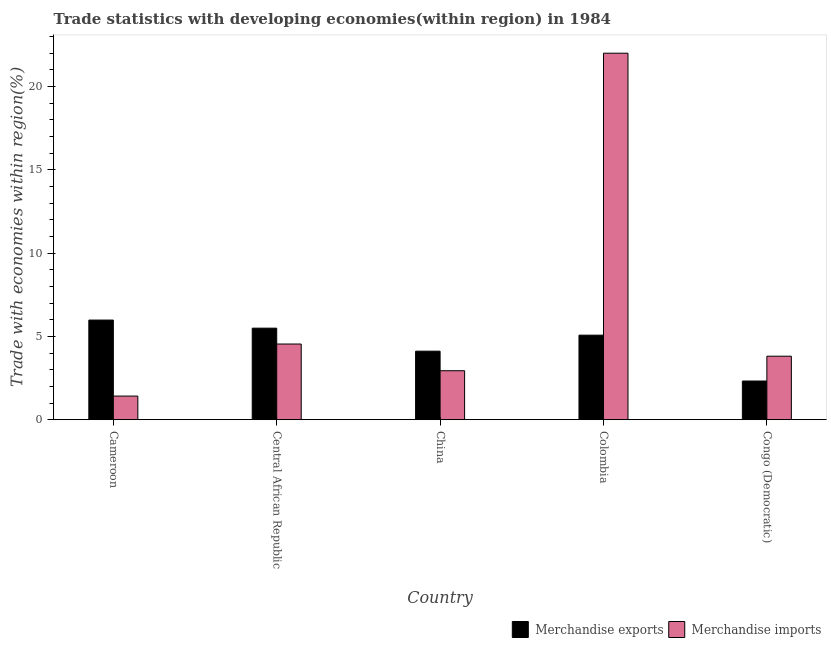How many different coloured bars are there?
Make the answer very short. 2. How many groups of bars are there?
Offer a very short reply. 5. How many bars are there on the 5th tick from the right?
Give a very brief answer. 2. What is the label of the 5th group of bars from the left?
Your response must be concise. Congo (Democratic). What is the merchandise exports in Central African Republic?
Offer a terse response. 5.5. Across all countries, what is the maximum merchandise imports?
Offer a very short reply. 22.01. Across all countries, what is the minimum merchandise exports?
Provide a short and direct response. 2.32. In which country was the merchandise imports minimum?
Offer a very short reply. Cameroon. What is the total merchandise imports in the graph?
Offer a terse response. 34.72. What is the difference between the merchandise imports in Central African Republic and that in Congo (Democratic)?
Your response must be concise. 0.73. What is the difference between the merchandise imports in Congo (Democratic) and the merchandise exports in Cameroon?
Your response must be concise. -2.17. What is the average merchandise exports per country?
Offer a terse response. 4.6. What is the difference between the merchandise exports and merchandise imports in Congo (Democratic)?
Ensure brevity in your answer.  -1.49. In how many countries, is the merchandise exports greater than 20 %?
Keep it short and to the point. 0. What is the ratio of the merchandise exports in Cameroon to that in Congo (Democratic)?
Ensure brevity in your answer.  2.58. Is the merchandise imports in China less than that in Colombia?
Give a very brief answer. Yes. What is the difference between the highest and the second highest merchandise exports?
Your response must be concise. 0.49. What is the difference between the highest and the lowest merchandise exports?
Keep it short and to the point. 3.66. In how many countries, is the merchandise exports greater than the average merchandise exports taken over all countries?
Keep it short and to the point. 3. Is the sum of the merchandise imports in Colombia and Congo (Democratic) greater than the maximum merchandise exports across all countries?
Your response must be concise. Yes. How many bars are there?
Provide a succinct answer. 10. How many countries are there in the graph?
Your answer should be very brief. 5. Does the graph contain any zero values?
Offer a very short reply. No. Where does the legend appear in the graph?
Make the answer very short. Bottom right. How many legend labels are there?
Give a very brief answer. 2. How are the legend labels stacked?
Ensure brevity in your answer.  Horizontal. What is the title of the graph?
Your answer should be very brief. Trade statistics with developing economies(within region) in 1984. What is the label or title of the X-axis?
Make the answer very short. Country. What is the label or title of the Y-axis?
Your answer should be compact. Trade with economies within region(%). What is the Trade with economies within region(%) in Merchandise exports in Cameroon?
Make the answer very short. 5.98. What is the Trade with economies within region(%) in Merchandise imports in Cameroon?
Provide a succinct answer. 1.42. What is the Trade with economies within region(%) in Merchandise exports in Central African Republic?
Offer a terse response. 5.5. What is the Trade with economies within region(%) in Merchandise imports in Central African Republic?
Offer a very short reply. 4.54. What is the Trade with economies within region(%) in Merchandise exports in China?
Provide a succinct answer. 4.11. What is the Trade with economies within region(%) of Merchandise imports in China?
Offer a very short reply. 2.94. What is the Trade with economies within region(%) in Merchandise exports in Colombia?
Keep it short and to the point. 5.08. What is the Trade with economies within region(%) of Merchandise imports in Colombia?
Offer a very short reply. 22.01. What is the Trade with economies within region(%) in Merchandise exports in Congo (Democratic)?
Your response must be concise. 2.32. What is the Trade with economies within region(%) of Merchandise imports in Congo (Democratic)?
Your answer should be very brief. 3.81. Across all countries, what is the maximum Trade with economies within region(%) in Merchandise exports?
Your response must be concise. 5.98. Across all countries, what is the maximum Trade with economies within region(%) in Merchandise imports?
Ensure brevity in your answer.  22.01. Across all countries, what is the minimum Trade with economies within region(%) of Merchandise exports?
Your answer should be compact. 2.32. Across all countries, what is the minimum Trade with economies within region(%) in Merchandise imports?
Your answer should be compact. 1.42. What is the total Trade with economies within region(%) of Merchandise exports in the graph?
Provide a succinct answer. 22.99. What is the total Trade with economies within region(%) in Merchandise imports in the graph?
Offer a very short reply. 34.72. What is the difference between the Trade with economies within region(%) in Merchandise exports in Cameroon and that in Central African Republic?
Make the answer very short. 0.49. What is the difference between the Trade with economies within region(%) in Merchandise imports in Cameroon and that in Central African Republic?
Your response must be concise. -3.13. What is the difference between the Trade with economies within region(%) in Merchandise exports in Cameroon and that in China?
Offer a very short reply. 1.87. What is the difference between the Trade with economies within region(%) in Merchandise imports in Cameroon and that in China?
Offer a terse response. -1.52. What is the difference between the Trade with economies within region(%) in Merchandise exports in Cameroon and that in Colombia?
Your answer should be very brief. 0.91. What is the difference between the Trade with economies within region(%) of Merchandise imports in Cameroon and that in Colombia?
Keep it short and to the point. -20.59. What is the difference between the Trade with economies within region(%) of Merchandise exports in Cameroon and that in Congo (Democratic)?
Offer a very short reply. 3.66. What is the difference between the Trade with economies within region(%) of Merchandise imports in Cameroon and that in Congo (Democratic)?
Provide a succinct answer. -2.39. What is the difference between the Trade with economies within region(%) of Merchandise exports in Central African Republic and that in China?
Your answer should be very brief. 1.38. What is the difference between the Trade with economies within region(%) of Merchandise imports in Central African Republic and that in China?
Offer a very short reply. 1.6. What is the difference between the Trade with economies within region(%) in Merchandise exports in Central African Republic and that in Colombia?
Keep it short and to the point. 0.42. What is the difference between the Trade with economies within region(%) of Merchandise imports in Central African Republic and that in Colombia?
Give a very brief answer. -17.46. What is the difference between the Trade with economies within region(%) in Merchandise exports in Central African Republic and that in Congo (Democratic)?
Your response must be concise. 3.17. What is the difference between the Trade with economies within region(%) of Merchandise imports in Central African Republic and that in Congo (Democratic)?
Ensure brevity in your answer.  0.73. What is the difference between the Trade with economies within region(%) in Merchandise exports in China and that in Colombia?
Give a very brief answer. -0.96. What is the difference between the Trade with economies within region(%) of Merchandise imports in China and that in Colombia?
Provide a short and direct response. -19.07. What is the difference between the Trade with economies within region(%) in Merchandise exports in China and that in Congo (Democratic)?
Provide a succinct answer. 1.79. What is the difference between the Trade with economies within region(%) of Merchandise imports in China and that in Congo (Democratic)?
Provide a succinct answer. -0.87. What is the difference between the Trade with economies within region(%) in Merchandise exports in Colombia and that in Congo (Democratic)?
Give a very brief answer. 2.75. What is the difference between the Trade with economies within region(%) of Merchandise imports in Colombia and that in Congo (Democratic)?
Provide a short and direct response. 18.19. What is the difference between the Trade with economies within region(%) in Merchandise exports in Cameroon and the Trade with economies within region(%) in Merchandise imports in Central African Republic?
Give a very brief answer. 1.44. What is the difference between the Trade with economies within region(%) in Merchandise exports in Cameroon and the Trade with economies within region(%) in Merchandise imports in China?
Your answer should be very brief. 3.04. What is the difference between the Trade with economies within region(%) in Merchandise exports in Cameroon and the Trade with economies within region(%) in Merchandise imports in Colombia?
Offer a terse response. -16.02. What is the difference between the Trade with economies within region(%) of Merchandise exports in Cameroon and the Trade with economies within region(%) of Merchandise imports in Congo (Democratic)?
Offer a terse response. 2.17. What is the difference between the Trade with economies within region(%) in Merchandise exports in Central African Republic and the Trade with economies within region(%) in Merchandise imports in China?
Provide a short and direct response. 2.56. What is the difference between the Trade with economies within region(%) of Merchandise exports in Central African Republic and the Trade with economies within region(%) of Merchandise imports in Colombia?
Your answer should be compact. -16.51. What is the difference between the Trade with economies within region(%) of Merchandise exports in Central African Republic and the Trade with economies within region(%) of Merchandise imports in Congo (Democratic)?
Ensure brevity in your answer.  1.68. What is the difference between the Trade with economies within region(%) in Merchandise exports in China and the Trade with economies within region(%) in Merchandise imports in Colombia?
Ensure brevity in your answer.  -17.89. What is the difference between the Trade with economies within region(%) in Merchandise exports in China and the Trade with economies within region(%) in Merchandise imports in Congo (Democratic)?
Make the answer very short. 0.3. What is the difference between the Trade with economies within region(%) in Merchandise exports in Colombia and the Trade with economies within region(%) in Merchandise imports in Congo (Democratic)?
Ensure brevity in your answer.  1.26. What is the average Trade with economies within region(%) of Merchandise exports per country?
Ensure brevity in your answer.  4.6. What is the average Trade with economies within region(%) in Merchandise imports per country?
Ensure brevity in your answer.  6.94. What is the difference between the Trade with economies within region(%) in Merchandise exports and Trade with economies within region(%) in Merchandise imports in Cameroon?
Provide a short and direct response. 4.56. What is the difference between the Trade with economies within region(%) of Merchandise exports and Trade with economies within region(%) of Merchandise imports in Central African Republic?
Your answer should be very brief. 0.95. What is the difference between the Trade with economies within region(%) of Merchandise exports and Trade with economies within region(%) of Merchandise imports in China?
Give a very brief answer. 1.17. What is the difference between the Trade with economies within region(%) in Merchandise exports and Trade with economies within region(%) in Merchandise imports in Colombia?
Offer a very short reply. -16.93. What is the difference between the Trade with economies within region(%) in Merchandise exports and Trade with economies within region(%) in Merchandise imports in Congo (Democratic)?
Offer a very short reply. -1.49. What is the ratio of the Trade with economies within region(%) of Merchandise exports in Cameroon to that in Central African Republic?
Give a very brief answer. 1.09. What is the ratio of the Trade with economies within region(%) in Merchandise imports in Cameroon to that in Central African Republic?
Your answer should be compact. 0.31. What is the ratio of the Trade with economies within region(%) of Merchandise exports in Cameroon to that in China?
Offer a terse response. 1.45. What is the ratio of the Trade with economies within region(%) of Merchandise imports in Cameroon to that in China?
Your response must be concise. 0.48. What is the ratio of the Trade with economies within region(%) in Merchandise exports in Cameroon to that in Colombia?
Your answer should be compact. 1.18. What is the ratio of the Trade with economies within region(%) in Merchandise imports in Cameroon to that in Colombia?
Provide a short and direct response. 0.06. What is the ratio of the Trade with economies within region(%) in Merchandise exports in Cameroon to that in Congo (Democratic)?
Offer a terse response. 2.58. What is the ratio of the Trade with economies within region(%) in Merchandise imports in Cameroon to that in Congo (Democratic)?
Your answer should be compact. 0.37. What is the ratio of the Trade with economies within region(%) of Merchandise exports in Central African Republic to that in China?
Ensure brevity in your answer.  1.34. What is the ratio of the Trade with economies within region(%) in Merchandise imports in Central African Republic to that in China?
Make the answer very short. 1.55. What is the ratio of the Trade with economies within region(%) of Merchandise exports in Central African Republic to that in Colombia?
Ensure brevity in your answer.  1.08. What is the ratio of the Trade with economies within region(%) of Merchandise imports in Central African Republic to that in Colombia?
Your answer should be compact. 0.21. What is the ratio of the Trade with economies within region(%) of Merchandise exports in Central African Republic to that in Congo (Democratic)?
Your answer should be very brief. 2.37. What is the ratio of the Trade with economies within region(%) in Merchandise imports in Central African Republic to that in Congo (Democratic)?
Your response must be concise. 1.19. What is the ratio of the Trade with economies within region(%) of Merchandise exports in China to that in Colombia?
Ensure brevity in your answer.  0.81. What is the ratio of the Trade with economies within region(%) of Merchandise imports in China to that in Colombia?
Your answer should be compact. 0.13. What is the ratio of the Trade with economies within region(%) in Merchandise exports in China to that in Congo (Democratic)?
Your response must be concise. 1.77. What is the ratio of the Trade with economies within region(%) in Merchandise imports in China to that in Congo (Democratic)?
Make the answer very short. 0.77. What is the ratio of the Trade with economies within region(%) in Merchandise exports in Colombia to that in Congo (Democratic)?
Ensure brevity in your answer.  2.19. What is the ratio of the Trade with economies within region(%) in Merchandise imports in Colombia to that in Congo (Democratic)?
Keep it short and to the point. 5.77. What is the difference between the highest and the second highest Trade with economies within region(%) of Merchandise exports?
Keep it short and to the point. 0.49. What is the difference between the highest and the second highest Trade with economies within region(%) of Merchandise imports?
Keep it short and to the point. 17.46. What is the difference between the highest and the lowest Trade with economies within region(%) in Merchandise exports?
Your answer should be very brief. 3.66. What is the difference between the highest and the lowest Trade with economies within region(%) of Merchandise imports?
Make the answer very short. 20.59. 